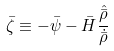<formula> <loc_0><loc_0><loc_500><loc_500>\bar { \zeta } \equiv - \bar { \psi } - \bar { H } \frac { \hat { \bar { \rho } } } { \dot { \bar { \rho } } }</formula> 